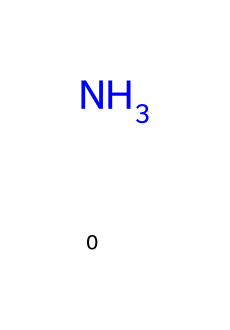What is the chemical name for the structure represented? The structure represents ammonia, which is a well-known cleaning agent. The nitrogen atom is bonded to three hydrogen atoms.
Answer: ammonia How many hydrogen atoms are present in this chemical? In the structure of ammonia, there are three hydrogen atoms bonded to one nitrogen atom.
Answer: 3 What type of bond forms between nitrogen and hydrogen in ammonia? The bonds between nitrogen and hydrogen in ammonia are covalent bonds, where electrons are shared between these atoms.
Answer: covalent What is the primary use of ammonia in stadiums? Ammonia is primarily used as a cleaning agent in stadiums, helping to clean surfaces effectively due to its strong degreasing properties.
Answer: cleaning agent Is ammonia a base or an acid? Ammonia is classified as a base, as it can accept protons (H+) in a chemical reaction.
Answer: base What is the pH level of ammonia when dissolved in water? When dissolved in water, ammonia typically has a pH level around 11 to 12, indicating it is a basic solution.
Answer: 11-12 